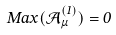Convert formula to latex. <formula><loc_0><loc_0><loc_500><loc_500>M a x ( \mathcal { A } _ { \mu } ^ { ( 1 ) } ) = 0</formula> 